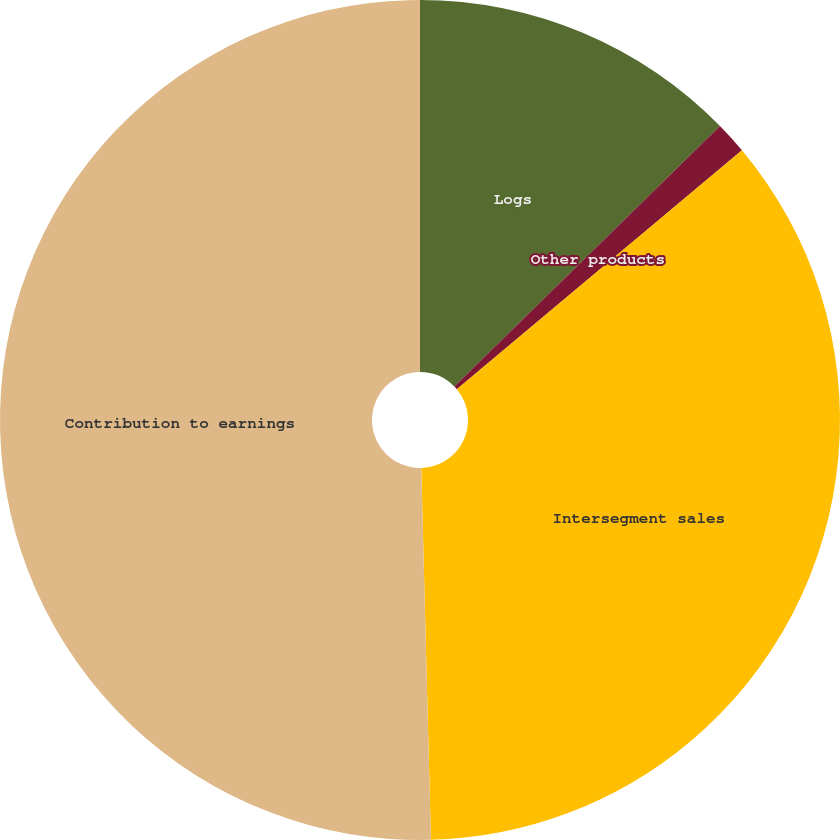Convert chart to OTSL. <chart><loc_0><loc_0><loc_500><loc_500><pie_chart><fcel>Logs<fcel>Other products<fcel>Intersegment sales<fcel>Contribution to earnings<nl><fcel>12.66%<fcel>1.24%<fcel>35.68%<fcel>50.41%<nl></chart> 